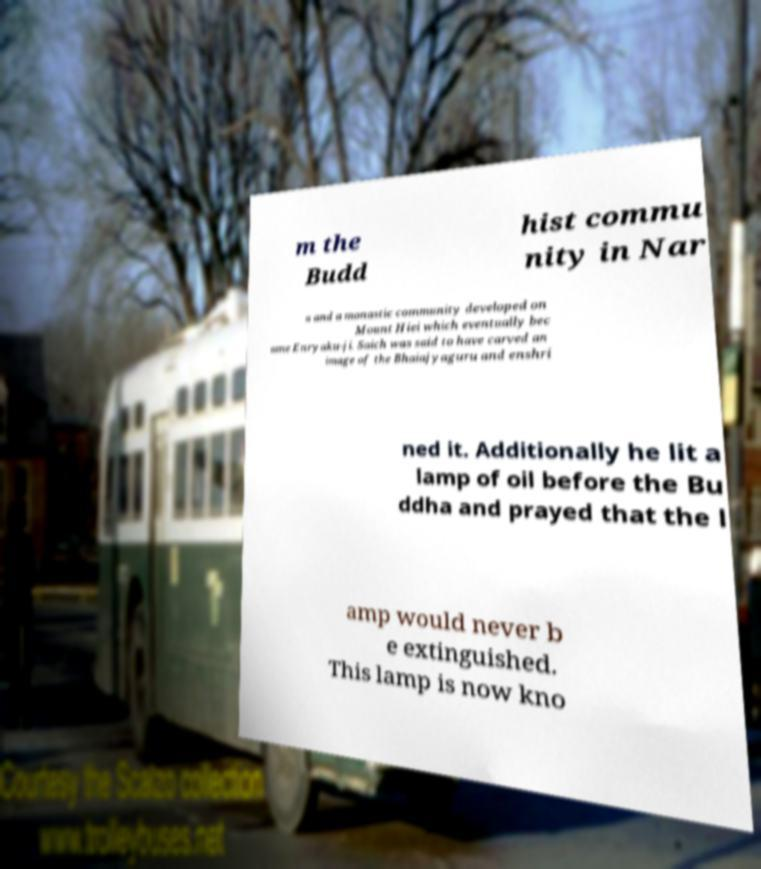Can you accurately transcribe the text from the provided image for me? m the Budd hist commu nity in Nar a and a monastic community developed on Mount Hiei which eventually bec ame Enryaku-ji. Saich was said to have carved an image of the Bhaiajyaguru and enshri ned it. Additionally he lit a lamp of oil before the Bu ddha and prayed that the l amp would never b e extinguished. This lamp is now kno 